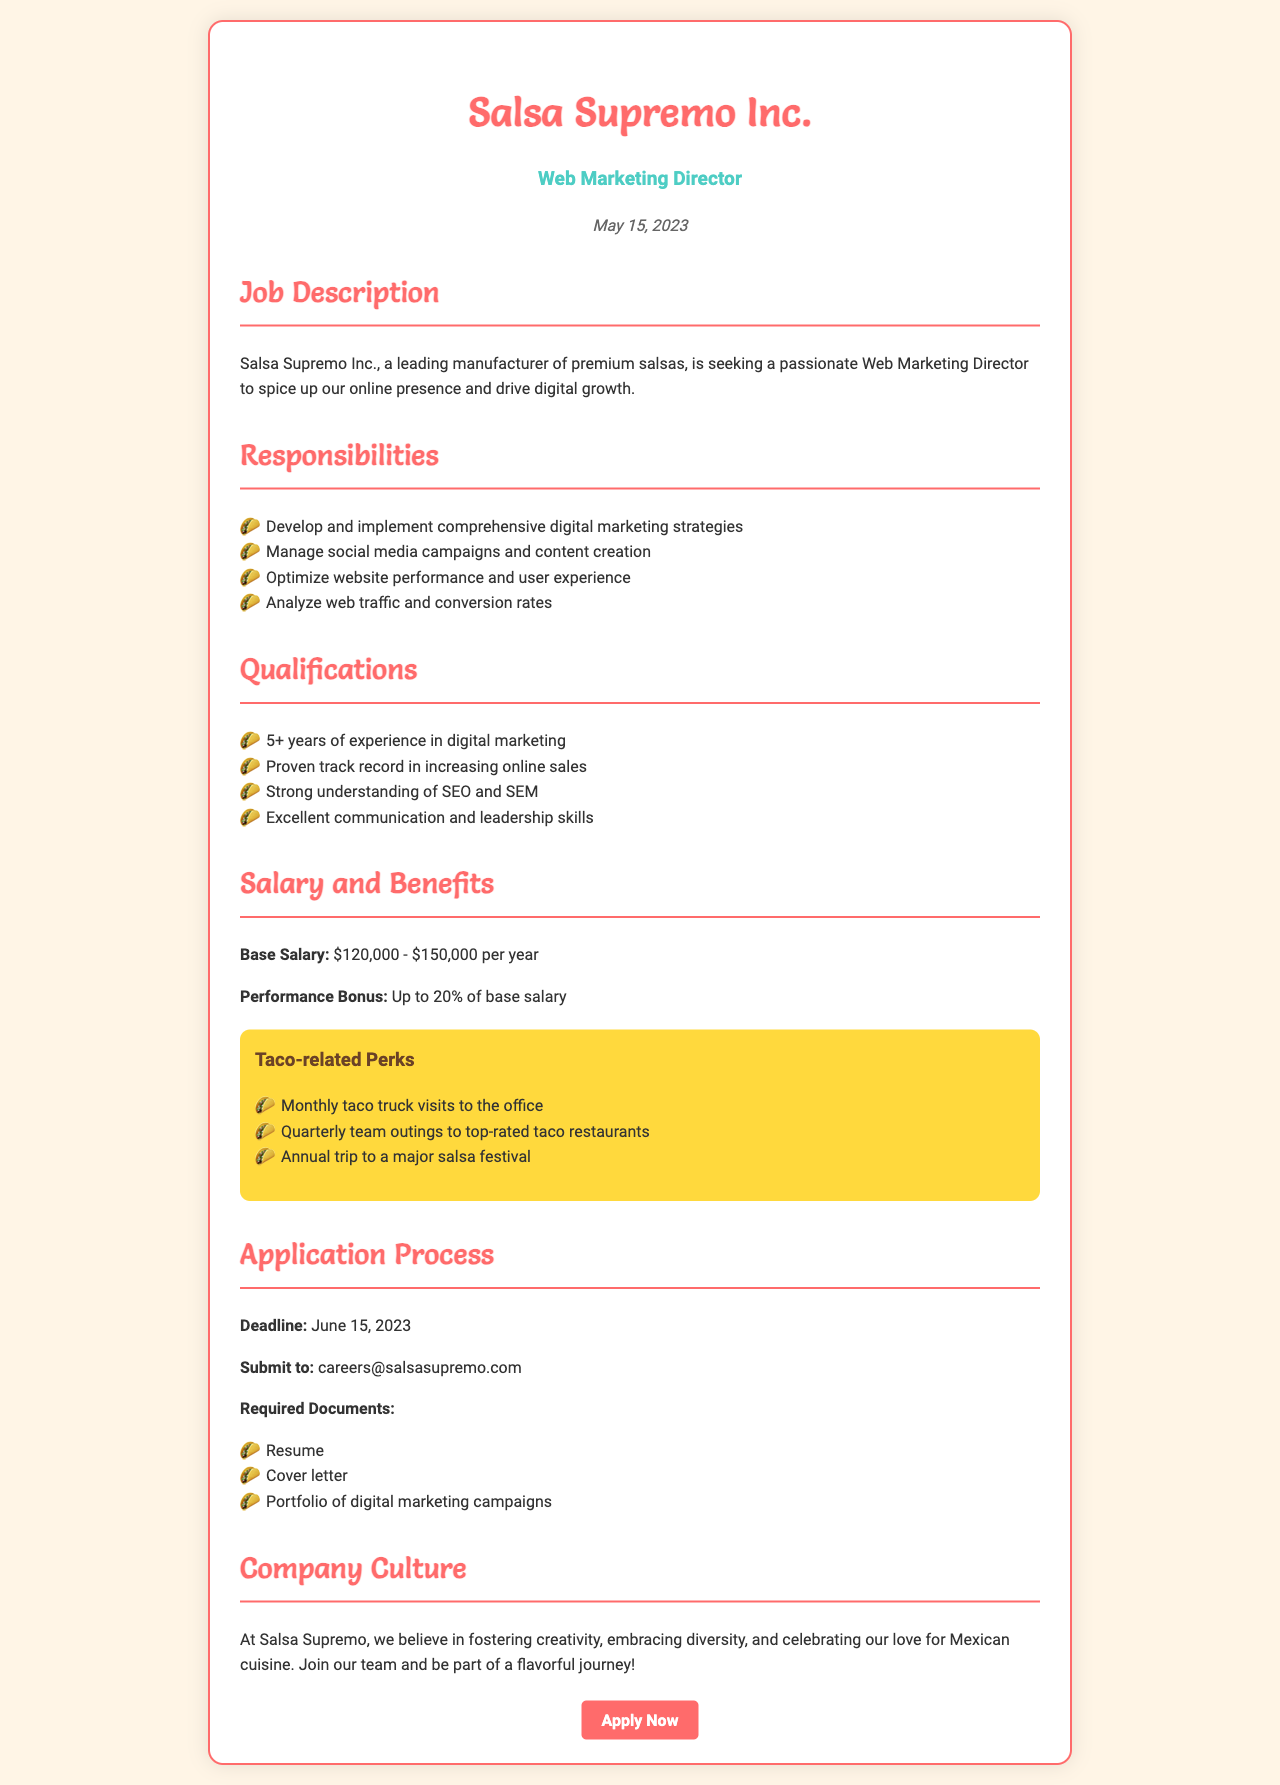what is the job title? The job title of the position offered is clearly stated in the document.
Answer: Web Marketing Director what is the salary range? The document specifies the base salary range as indicated in the salary and benefits section.
Answer: $120,000 - $150,000 per year when is the application deadline? The deadline for submitting applications is mentioned in the application process section.
Answer: June 15, 2023 what are the required documents for application? The document lists the necessary documents needed to apply for the position.
Answer: Resume, Cover letter, Portfolio of digital marketing campaigns how much can the performance bonus reach? The document provides information about the performance bonus in the salary and benefits section.
Answer: Up to 20% of base salary what are the taco-related perks? The perks related to tacos are outlined in a specific section dedicated to taco-related benefits.
Answer: Monthly taco truck visits to the office, Quarterly team outings to top-rated taco restaurants, Annual trip to a major salsa festival what is one key qualification for the role? Specific qualifications required for the position are detailed in the qualifications section of the document.
Answer: 5+ years of experience in digital marketing who should applications be submitted to? The document specifies the email address for submission of applications in the application process section.
Answer: careers@salsasupremo.com 